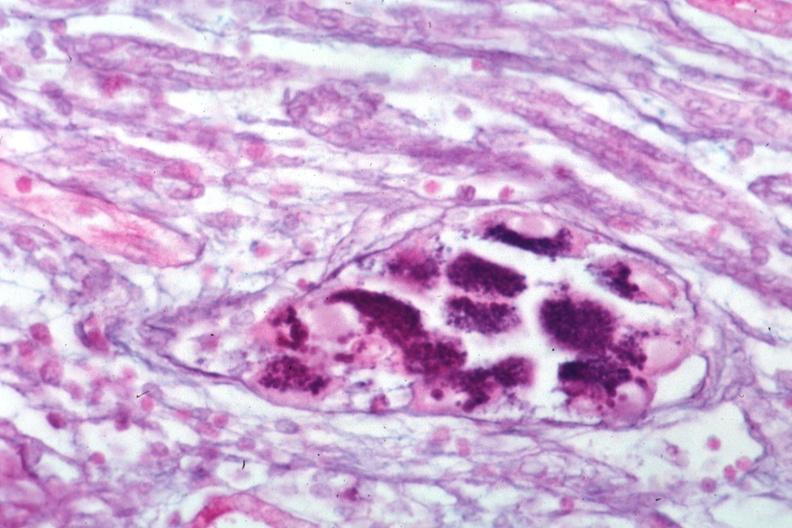what is present?
Answer the question using a single word or phrase. Cytomegalovirus 